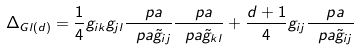<formula> <loc_0><loc_0><loc_500><loc_500>\Delta _ { G l ( d ) } = \frac { 1 } { 4 } g _ { i k } g _ { j l } \frac { \ p a } { \ p a \tilde { g } _ { i j } } \frac { \ p a } { \ p a \tilde { g } _ { k l } } + \frac { d + 1 } { 4 } g _ { i j } \frac { \ p a } { \ p a \tilde { g } _ { i j } }</formula> 